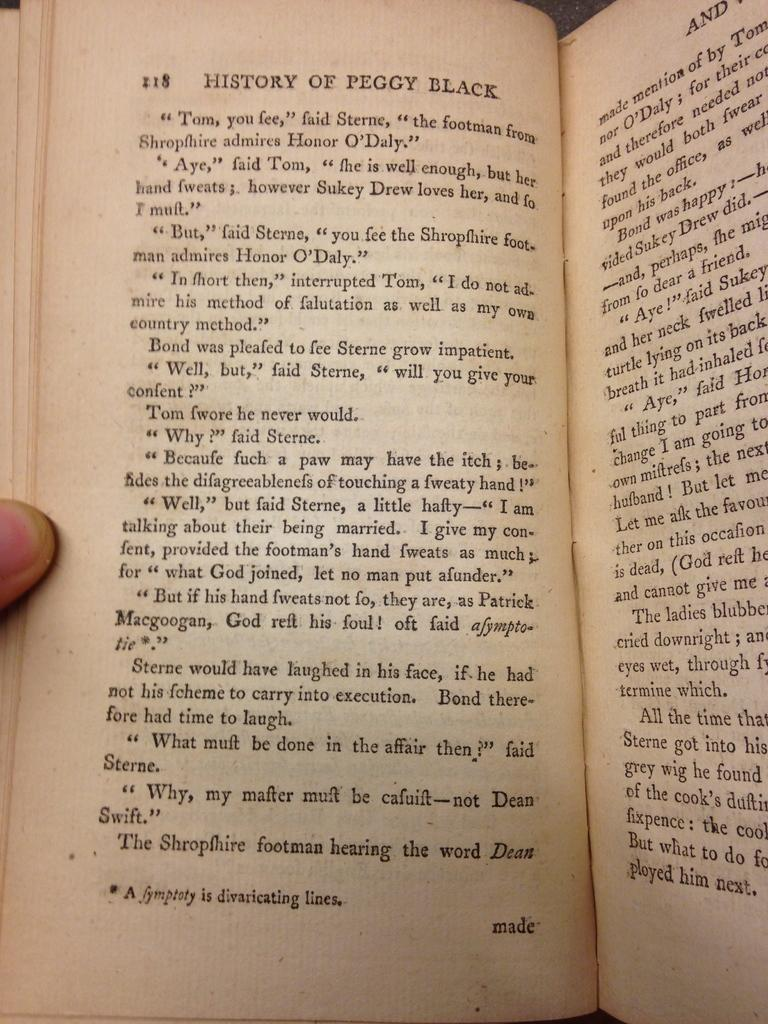<image>
Create a compact narrative representing the image presented. A History of Peggy Black is open to page 218 